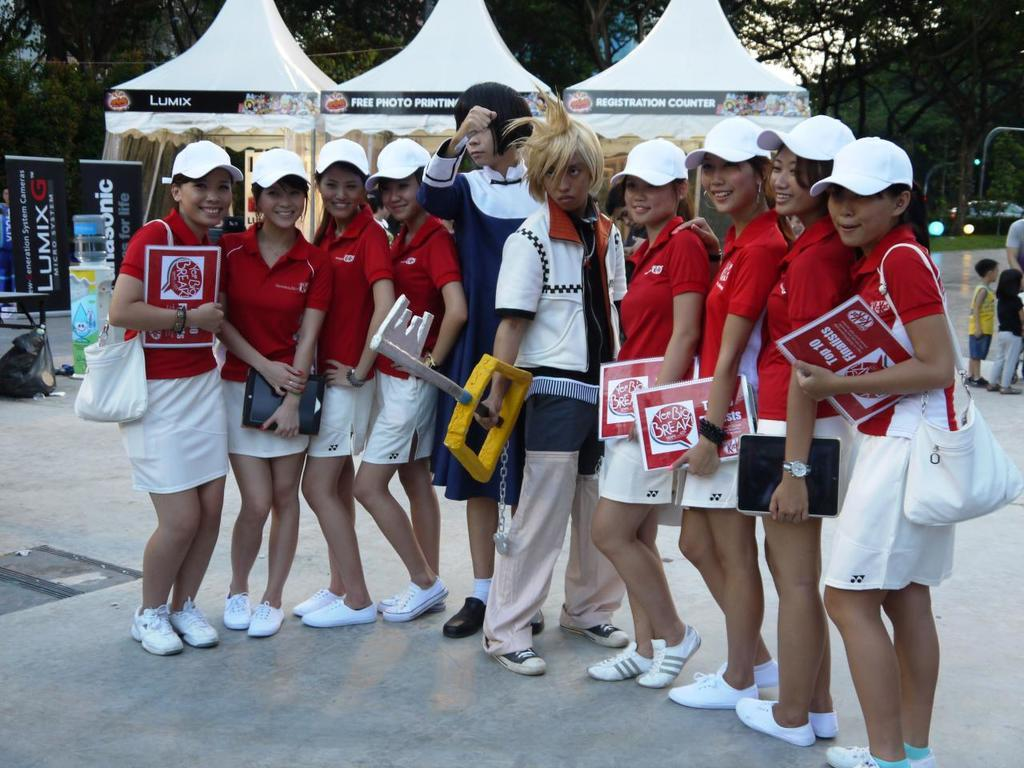<image>
Give a short and clear explanation of the subsequent image. Several people are gathered in front of tents, including one labelled Lumix. 